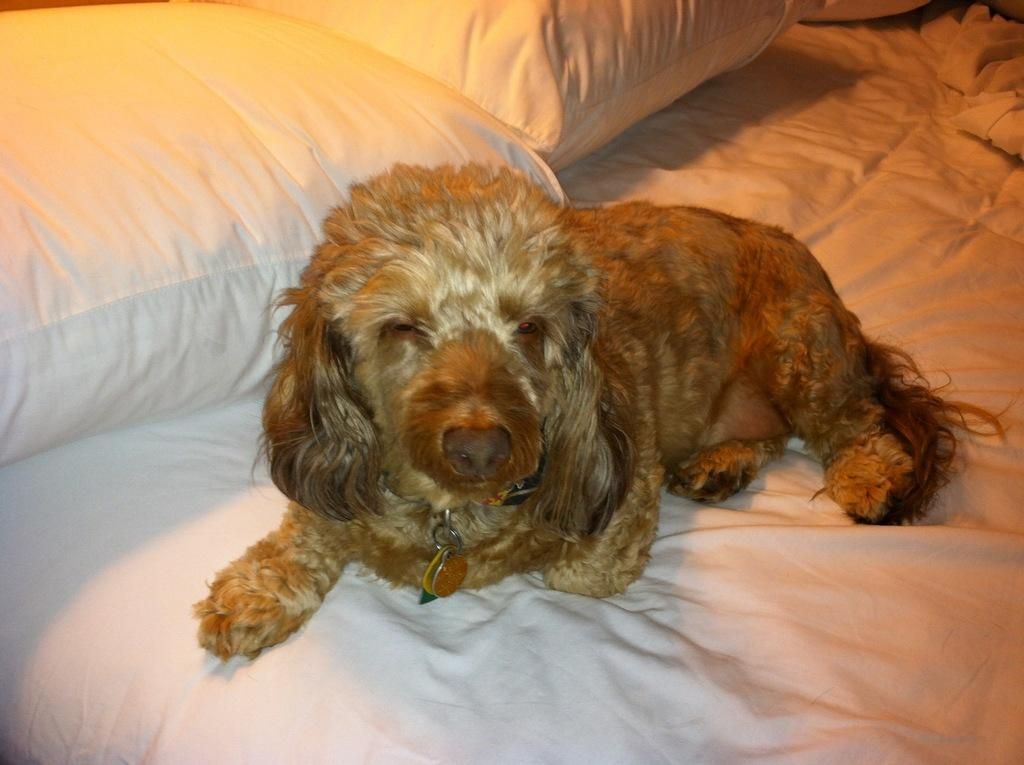What type of animal is present in the image? There is a dog in the image. Where is the dog located in the image? The dog is on a bed. What type of plane can be seen in the image? There is no plane present in the image; it features a dog on a bed. What type of tub is visible in the image? There is no tub present in the image; it features a dog on a bed. 